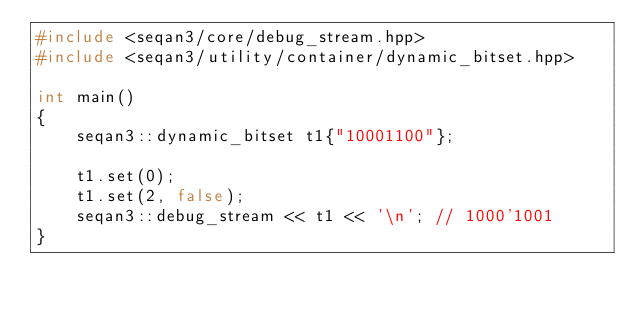<code> <loc_0><loc_0><loc_500><loc_500><_C++_>#include <seqan3/core/debug_stream.hpp>
#include <seqan3/utility/container/dynamic_bitset.hpp>

int main()
{
    seqan3::dynamic_bitset t1{"10001100"};

    t1.set(0);
    t1.set(2, false);
    seqan3::debug_stream << t1 << '\n'; // 1000'1001
}
</code> 